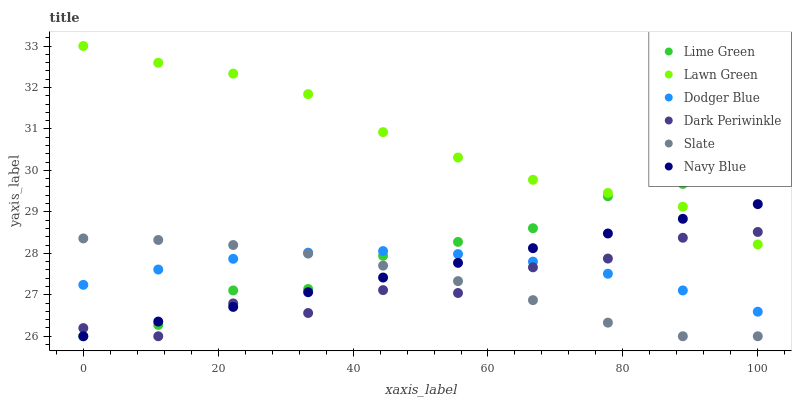Does Dark Periwinkle have the minimum area under the curve?
Answer yes or no. Yes. Does Lawn Green have the maximum area under the curve?
Answer yes or no. Yes. Does Navy Blue have the minimum area under the curve?
Answer yes or no. No. Does Navy Blue have the maximum area under the curve?
Answer yes or no. No. Is Navy Blue the smoothest?
Answer yes or no. Yes. Is Dark Periwinkle the roughest?
Answer yes or no. Yes. Is Slate the smoothest?
Answer yes or no. No. Is Slate the roughest?
Answer yes or no. No. Does Navy Blue have the lowest value?
Answer yes or no. Yes. Does Dodger Blue have the lowest value?
Answer yes or no. No. Does Lawn Green have the highest value?
Answer yes or no. Yes. Does Navy Blue have the highest value?
Answer yes or no. No. Is Dodger Blue less than Lawn Green?
Answer yes or no. Yes. Is Lawn Green greater than Dodger Blue?
Answer yes or no. Yes. Does Dark Periwinkle intersect Lime Green?
Answer yes or no. Yes. Is Dark Periwinkle less than Lime Green?
Answer yes or no. No. Is Dark Periwinkle greater than Lime Green?
Answer yes or no. No. Does Dodger Blue intersect Lawn Green?
Answer yes or no. No. 